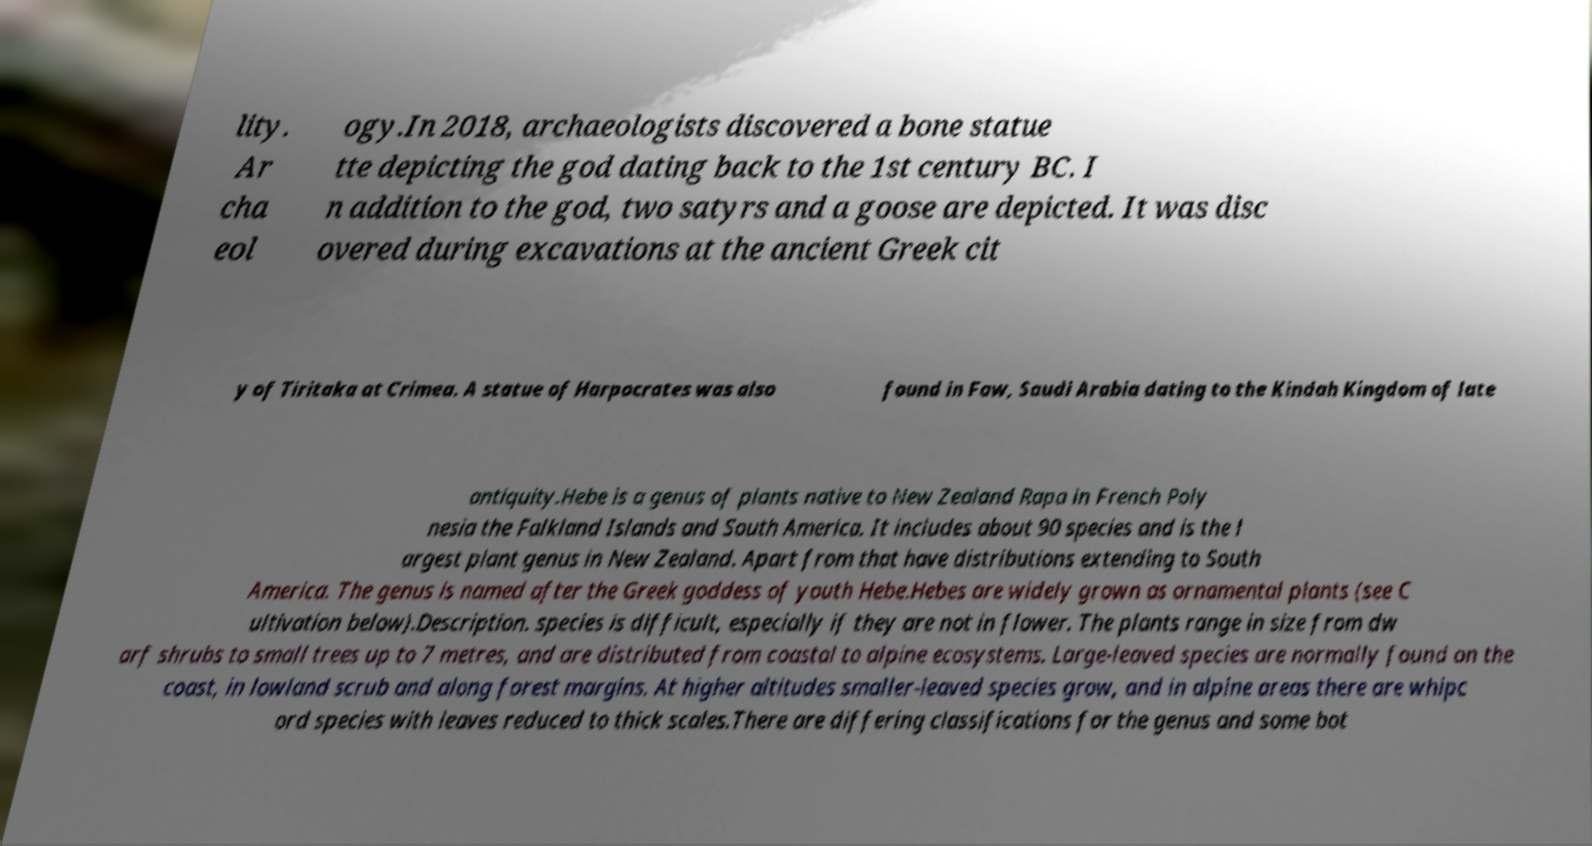I need the written content from this picture converted into text. Can you do that? lity. Ar cha eol ogy.In 2018, archaeologists discovered a bone statue tte depicting the god dating back to the 1st century BC. I n addition to the god, two satyrs and a goose are depicted. It was disc overed during excavations at the ancient Greek cit y of Tiritaka at Crimea. A statue of Harpocrates was also found in Faw, Saudi Arabia dating to the Kindah Kingdom of late antiquity.Hebe is a genus of plants native to New Zealand Rapa in French Poly nesia the Falkland Islands and South America. It includes about 90 species and is the l argest plant genus in New Zealand. Apart from that have distributions extending to South America. The genus is named after the Greek goddess of youth Hebe.Hebes are widely grown as ornamental plants (see C ultivation below).Description. species is difficult, especially if they are not in flower. The plants range in size from dw arf shrubs to small trees up to 7 metres, and are distributed from coastal to alpine ecosystems. Large-leaved species are normally found on the coast, in lowland scrub and along forest margins. At higher altitudes smaller-leaved species grow, and in alpine areas there are whipc ord species with leaves reduced to thick scales.There are differing classifications for the genus and some bot 